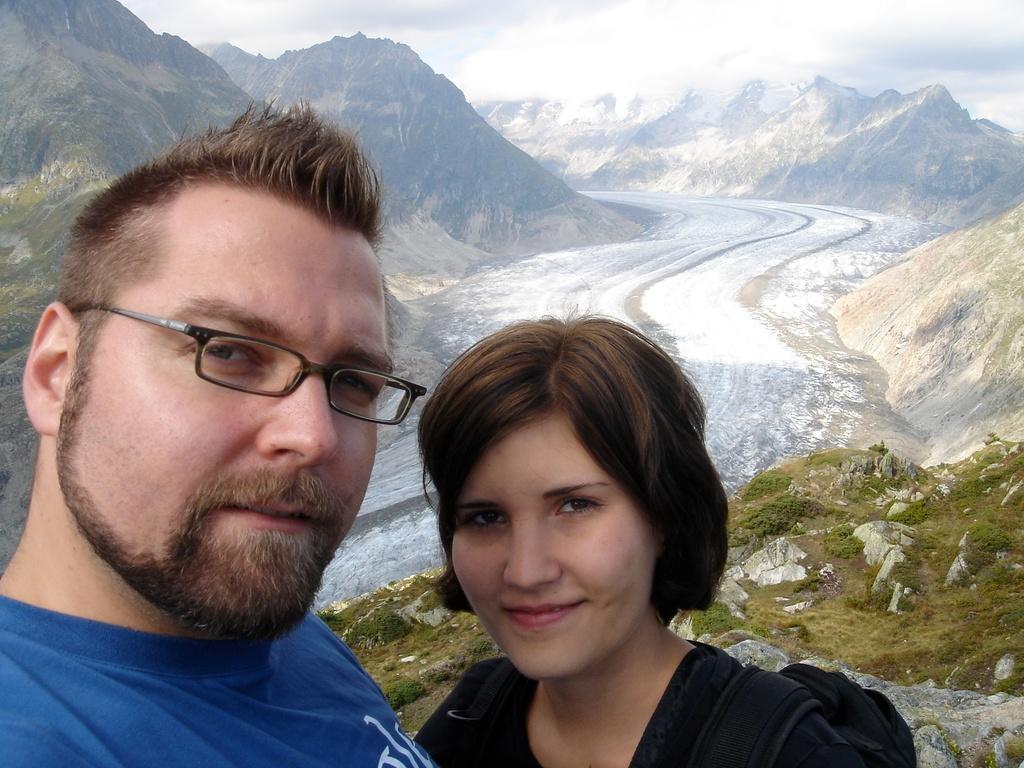Can you describe this image briefly? In this picture I can see a man is looking at his side, he wore blue color t-shirt. In the middle a woman is looking at this side. He wore black color t-shirt, in the middle there is the snow on the road. 